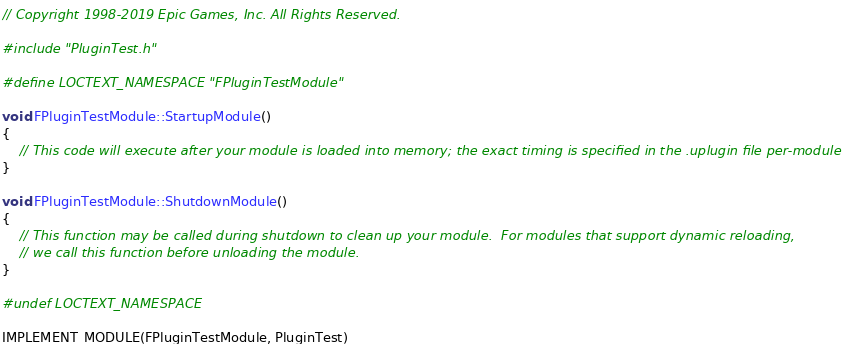<code> <loc_0><loc_0><loc_500><loc_500><_C++_>// Copyright 1998-2019 Epic Games, Inc. All Rights Reserved.

#include "PluginTest.h"

#define LOCTEXT_NAMESPACE "FPluginTestModule"

void FPluginTestModule::StartupModule()
{
	// This code will execute after your module is loaded into memory; the exact timing is specified in the .uplugin file per-module
}

void FPluginTestModule::ShutdownModule()
{
	// This function may be called during shutdown to clean up your module.  For modules that support dynamic reloading,
	// we call this function before unloading the module.
}

#undef LOCTEXT_NAMESPACE
	
IMPLEMENT_MODULE(FPluginTestModule, PluginTest)</code> 